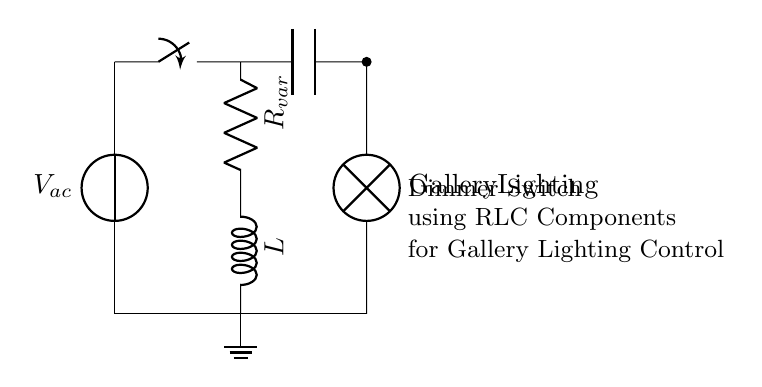What type of dimmer switch is used in this circuit? The circuit uses a dimmer switch utilizing RLC components. It specifies this in the label noting the "Dimmer Switch using RLC Components."
Answer: Dimmer switch What is the purpose of the inductor in this circuit? The inductor in an RLC circuit helps to store energy in a magnetic field and can influence the circuit's response to AC signals, making it vital for controlling the brightness of lighting. This is a characteristic function in dimmer switch applications.
Answer: Energy storage What is the connection of the lamp in the circuit? The lamp, representing gallery lighting, is connected in parallel with the capacitor and in series with the resistor and inductor. It receives the output signal to control brightness.
Answer: Parallel What component is labeled Rvar? Rvar stands for a variable resistor, which can be adjusted to change the resistance in the circuit, enabling control over the brightness of the connected load (the lamp).
Answer: Variable resistor How many components are connected in series? The resistor and inductor are connected in series; they are arranged one after the other in the circuit path before connecting to the common line that goes to the lamp.
Answer: Two 